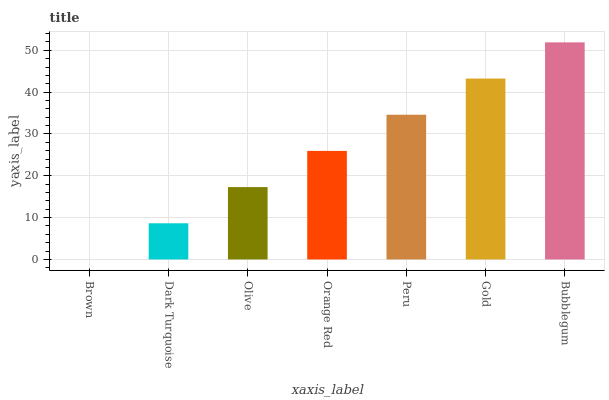Is Dark Turquoise the minimum?
Answer yes or no. No. Is Dark Turquoise the maximum?
Answer yes or no. No. Is Dark Turquoise greater than Brown?
Answer yes or no. Yes. Is Brown less than Dark Turquoise?
Answer yes or no. Yes. Is Brown greater than Dark Turquoise?
Answer yes or no. No. Is Dark Turquoise less than Brown?
Answer yes or no. No. Is Orange Red the high median?
Answer yes or no. Yes. Is Orange Red the low median?
Answer yes or no. Yes. Is Olive the high median?
Answer yes or no. No. Is Bubblegum the low median?
Answer yes or no. No. 